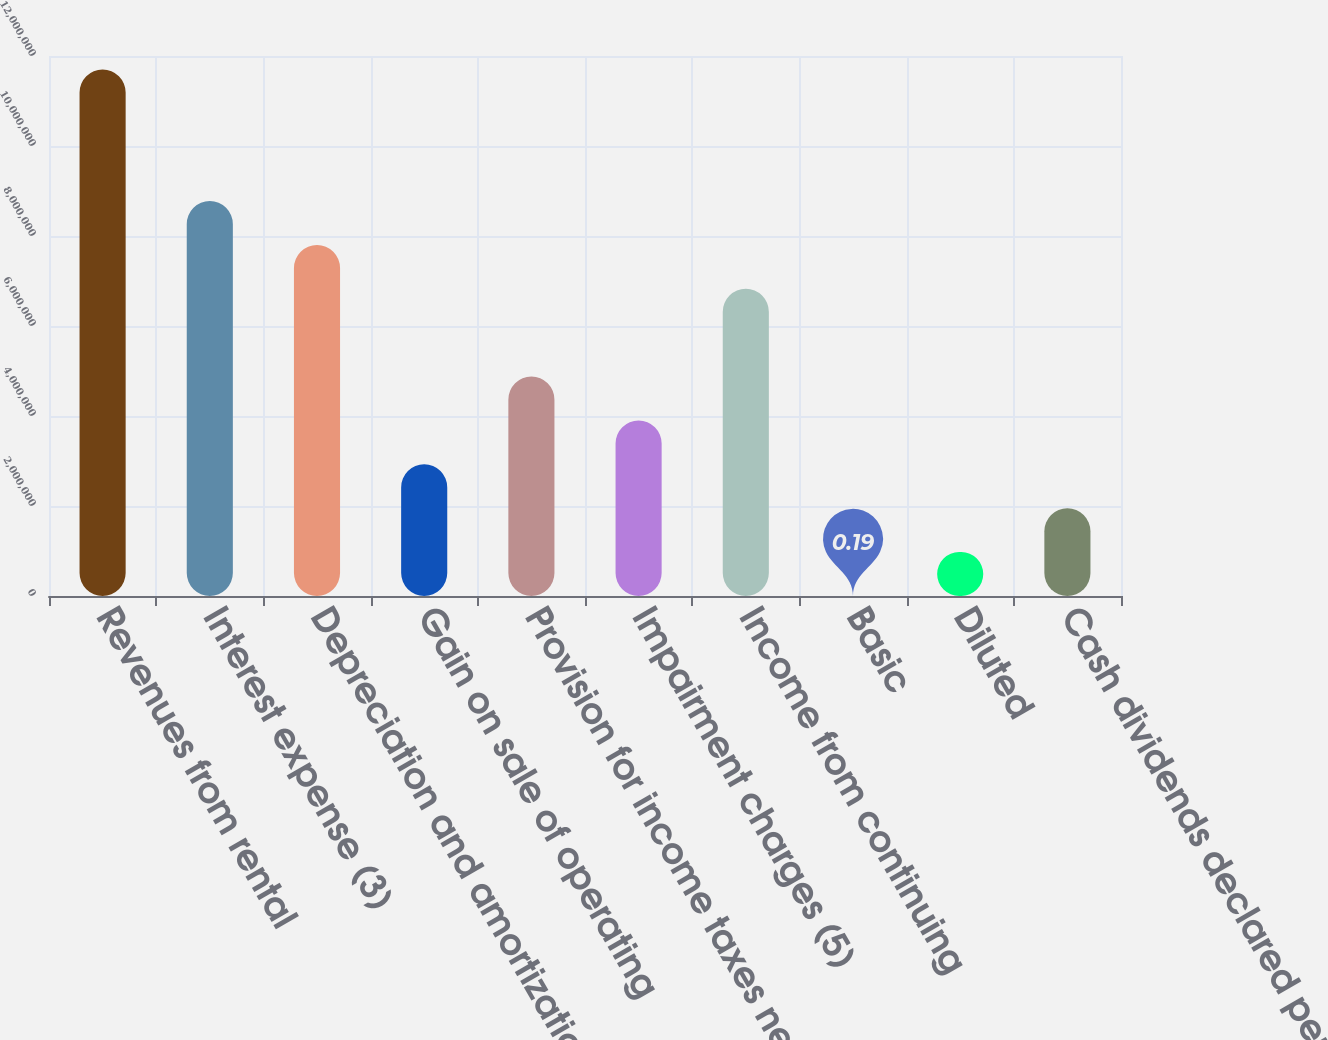Convert chart. <chart><loc_0><loc_0><loc_500><loc_500><bar_chart><fcel>Revenues from rental<fcel>Interest expense (3)<fcel>Depreciation and amortization<fcel>Gain on sale of operating<fcel>Provision for income taxes net<fcel>Impairment charges (5)<fcel>Income from continuing<fcel>Basic<fcel>Diluted<fcel>Cash dividends declared per<nl><fcel>1.17015e+07<fcel>8.77611e+06<fcel>7.80099e+06<fcel>2.92537e+06<fcel>4.87562e+06<fcel>3.90049e+06<fcel>6.82586e+06<fcel>0.19<fcel>975124<fcel>1.95025e+06<nl></chart> 